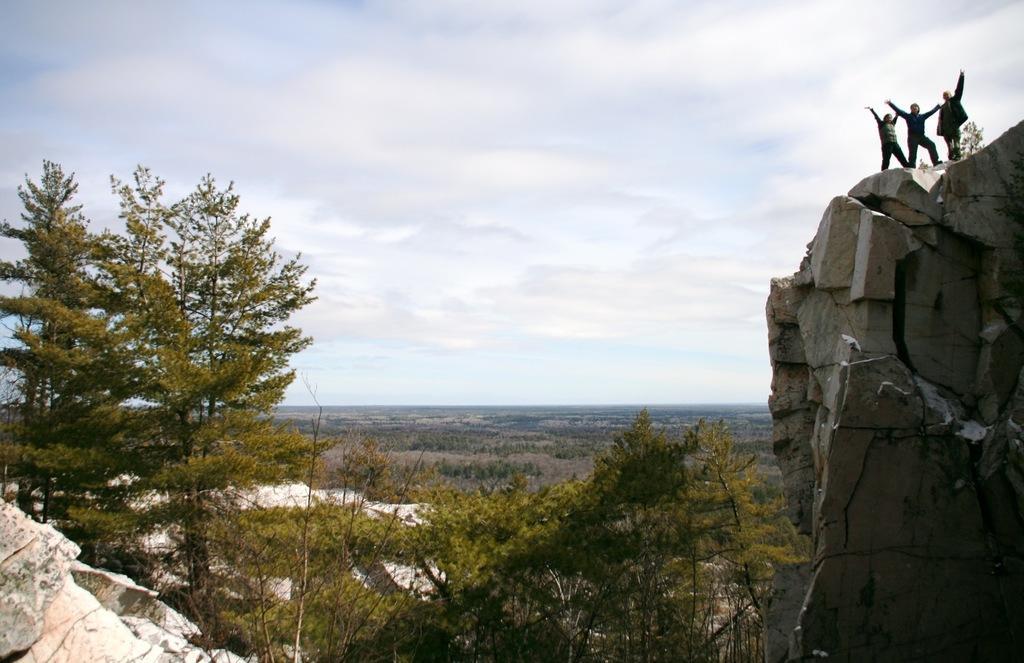In one or two sentences, can you explain what this image depicts? In this image we can see three people standing on a rock wall. There are many trees and also there are rocks. In the background there is sky. 